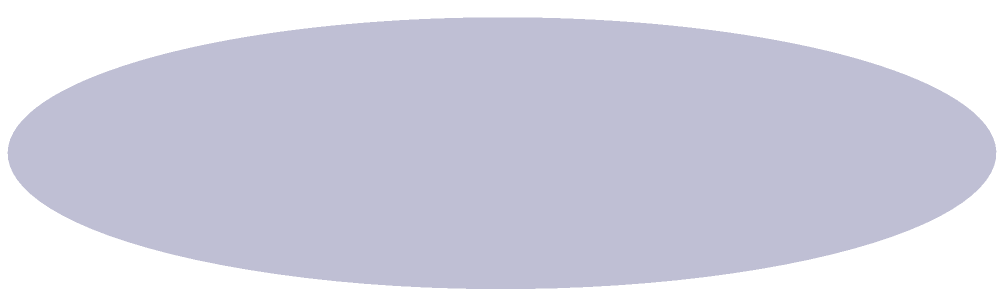As the public relations officer at the University of Toronto, you're preparing a press release about a new research project in the Mathematics Department. The project involves studying the properties of conical structures. To accurately represent the research, you need to calculate the volume of a cone with a radius of 6 meters and a height of 9 meters. What is the volume of this cone in cubic meters? To calculate the volume of a cone, we can follow these steps:

1. Recall the formula for the volume of a cone:
   $$V = \frac{1}{3}\pi r^2 h$$
   where $V$ is the volume, $r$ is the radius of the base, and $h$ is the height of the cone.

2. We are given:
   Radius ($r$) = 6 meters
   Height ($h$) = 9 meters

3. Substitute these values into the formula:
   $$V = \frac{1}{3}\pi (6^2) (9)$$

4. Simplify the expression:
   $$V = \frac{1}{3}\pi (36) (9)$$
   $$V = 108\pi$$

5. Calculate the final value (rounded to two decimal places):
   $$V \approx 339.29 \text{ cubic meters}$$

Therefore, the volume of the cone is approximately 339.29 cubic meters.
Answer: $339.29 \text{ m}^3$ 